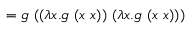<formula> <loc_0><loc_0><loc_500><loc_500>= g \ ( ( \lambda x . g \ ( x \ x ) ) \ ( \lambda x . g \ ( x \ x ) ) )</formula> 